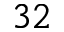Convert formula to latex. <formula><loc_0><loc_0><loc_500><loc_500>3 2</formula> 